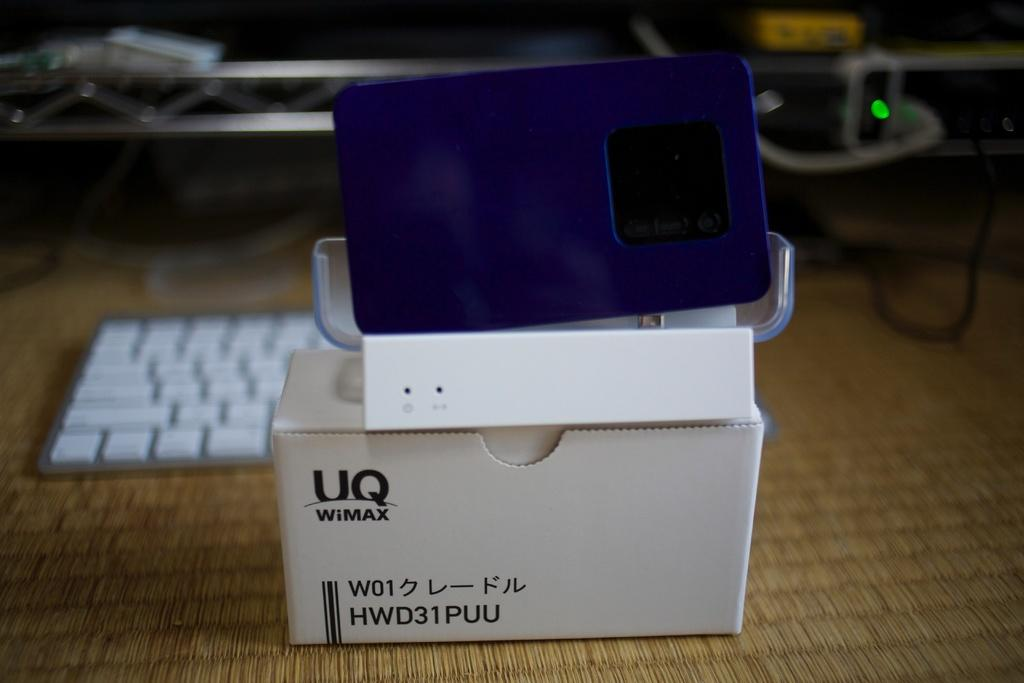<image>
Provide a brief description of the given image. A box that is labeled with the brand UQ WiMAX. 